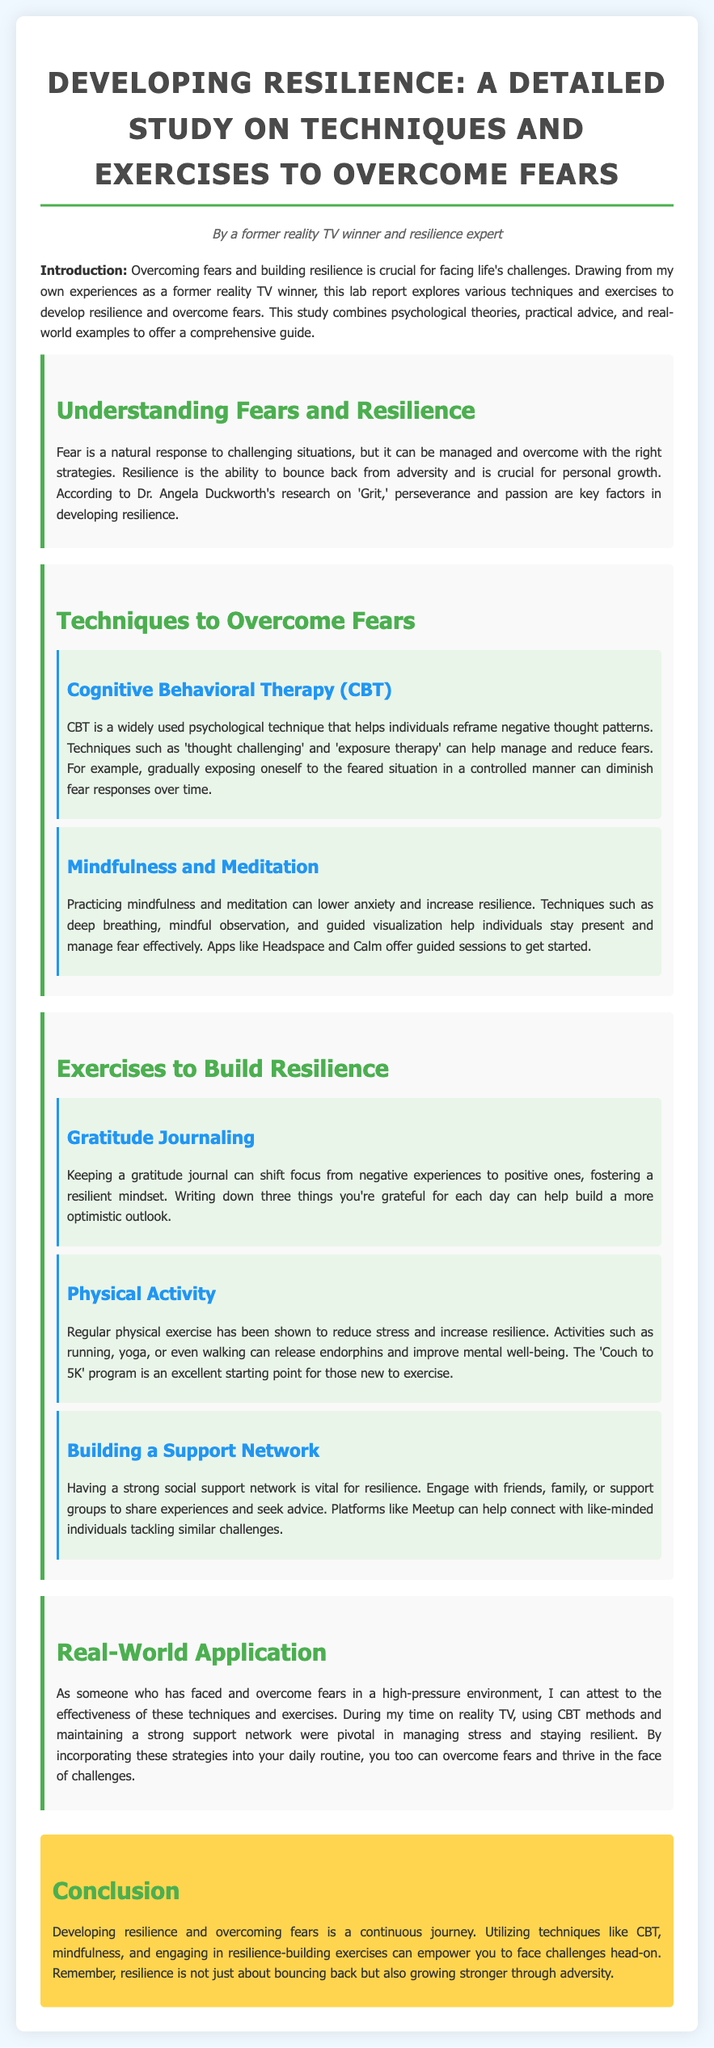What is the title of the lab report? The title of the lab report is mentioned at the beginning and focuses on developing resilience to overcome fears.
Answer: Developing Resilience: A Detailed Study on Techniques and Exercises to Overcome Fears Who is the author of the lab report? The author information is provided in the introduction section, which states the author's background.
Answer: A former reality TV winner and resilience expert What psychological technique is mentioned for overcoming fears? The section discusses specific techniques, and one of them is described in detail.
Answer: Cognitive Behavioral Therapy (CBT) What is one exercise suggested for building resilience? The report outlines various exercises, and one is specifically highlighted under the relevant section.
Answer: Gratitude Journaling What is the purpose of mindfulness and meditation according to the report? The document explains the benefits of mindfulness and meditation in relation to fear management.
Answer: Lower anxiety and increase resilience What method did the author find pivotal during their reality TV experience? The author reflects on specific strategies they employed during their experiences that helped them manage stress.
Answer: CBT methods How many things are suggested to write in a gratitude journal daily? The report specifies the number of items to be noted in the gratitude journaling exercise.
Answer: Three things What is one recommended app for mindfulness practice mentioned in the report? The report gives examples of resources for mindfulness and meditation.
Answer: Headspace What color is primarily used for the section titles in the document? The document describes the color used for the section headings, indicating how they stand out.
Answer: Green 